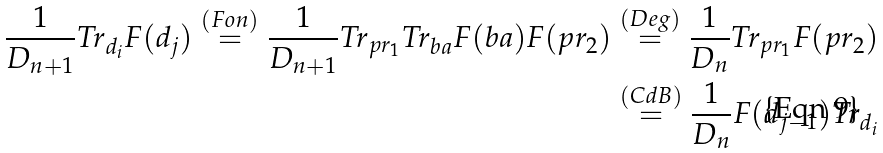<formula> <loc_0><loc_0><loc_500><loc_500>\frac { 1 } { D _ { n + 1 } } T r _ { d _ { i } } F ( d _ { j } ) \stackrel { ( F o n ) } { = } \frac { 1 } { D _ { n + 1 } } T r _ { p r _ { 1 } } T r _ { b a } F ( b a ) F ( p r _ { 2 } ) & \stackrel { ( D e g ) } { = } \frac { 1 } { D _ { n } } T r _ { p r _ { 1 } } F ( p r _ { 2 } ) \\ & \stackrel { ( C d B ) } { = } \frac { 1 } { D _ { n } } F ( d _ { j - 1 } ) T r _ { d _ { i } }</formula> 